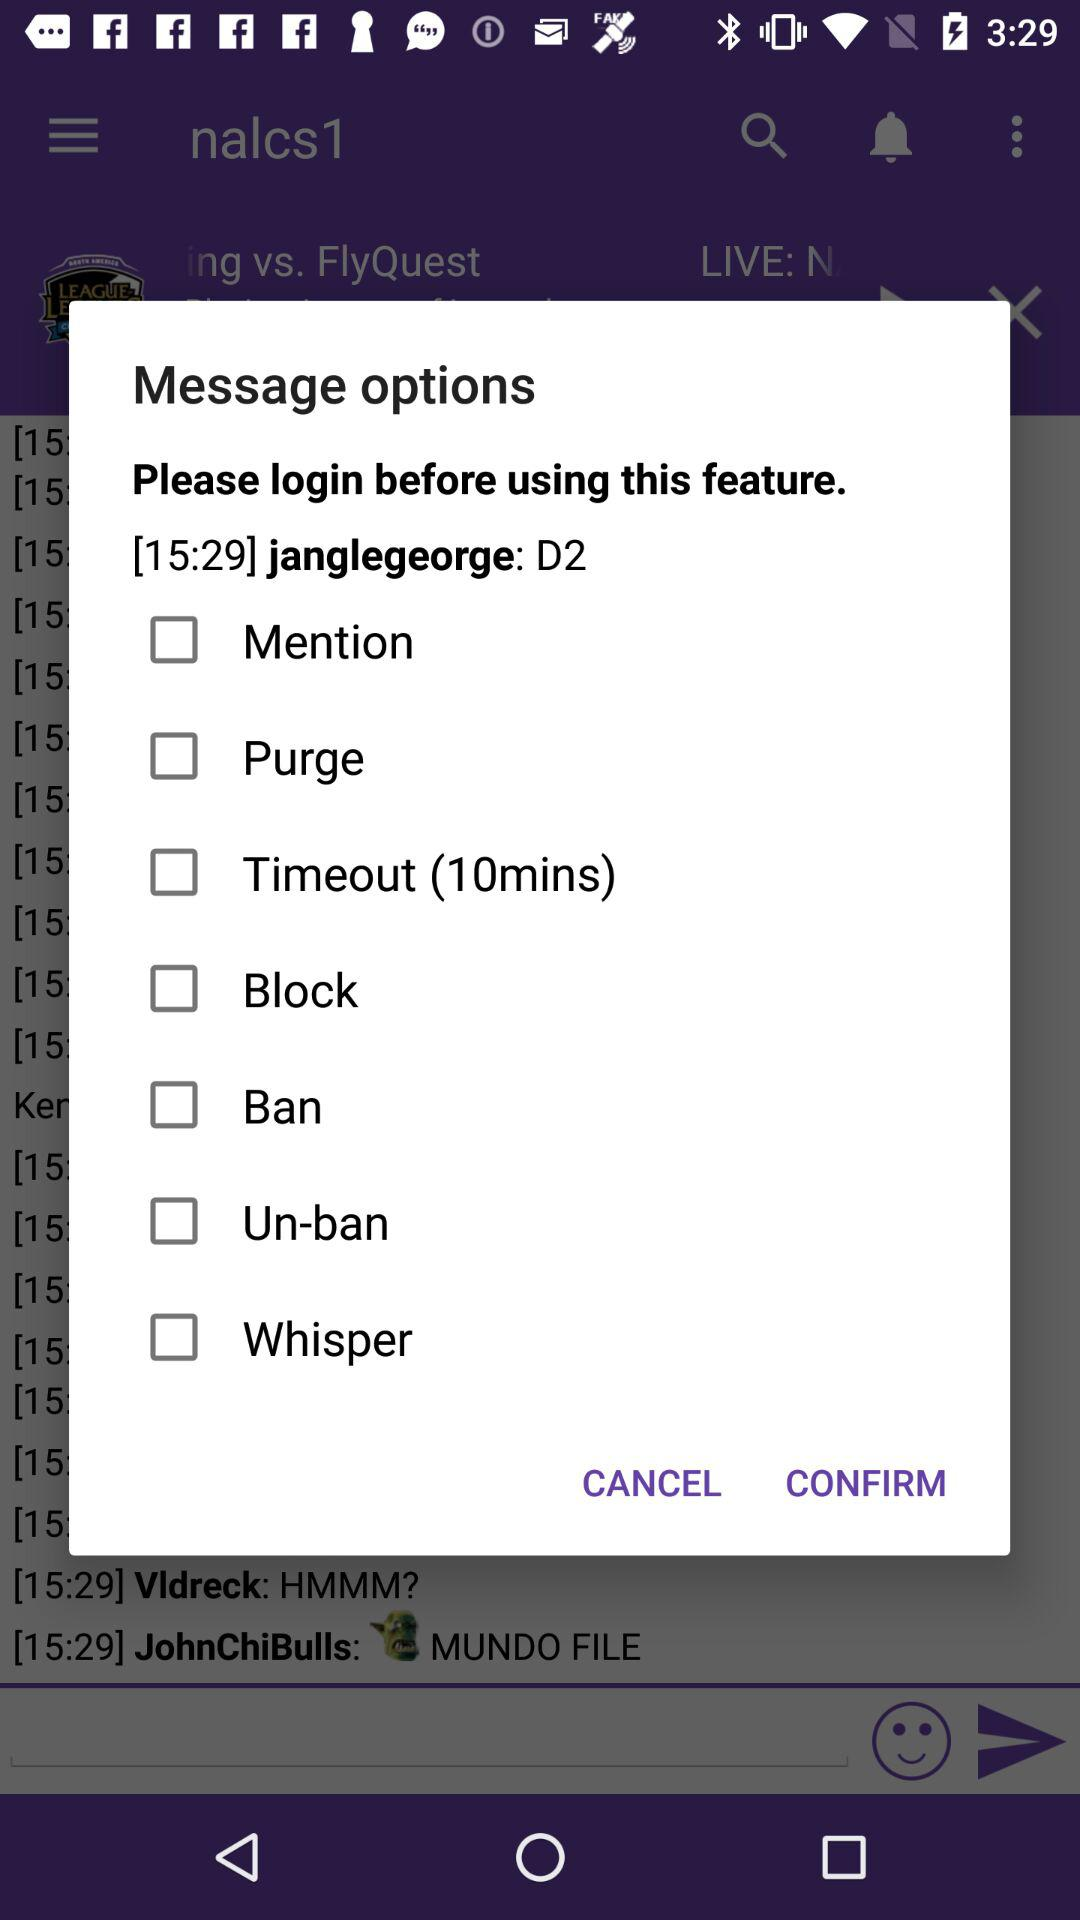What are the available message options? The available message options are "Mention", "Purge", "Timeout (10mins)", "Block", "Ban", "Un-ban" and "Whisper". 